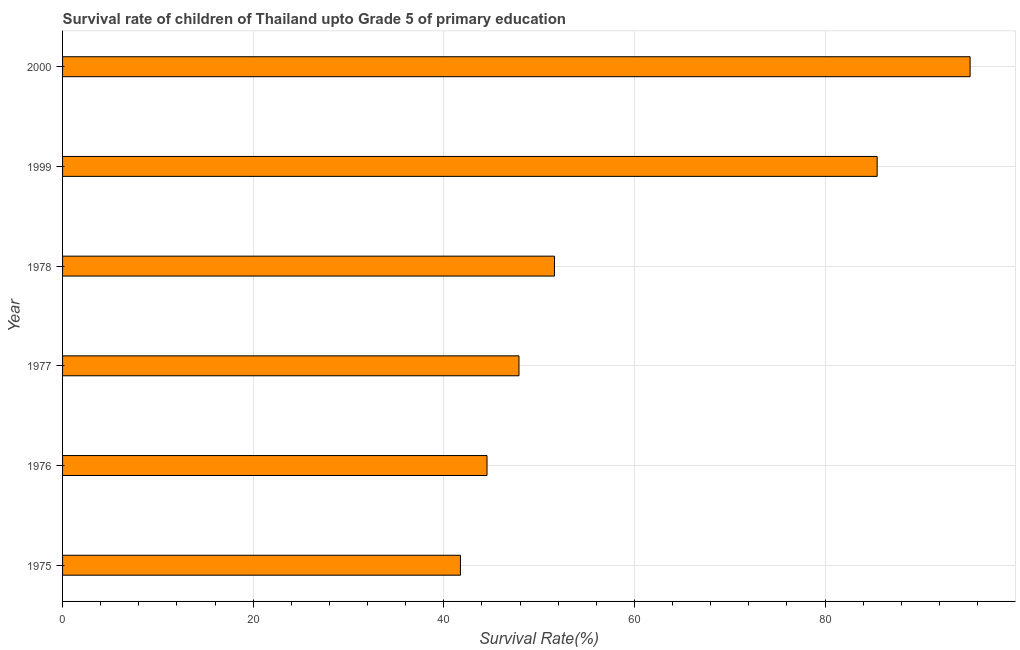Does the graph contain any zero values?
Provide a succinct answer. No. What is the title of the graph?
Your answer should be compact. Survival rate of children of Thailand upto Grade 5 of primary education. What is the label or title of the X-axis?
Keep it short and to the point. Survival Rate(%). What is the survival rate in 2000?
Ensure brevity in your answer.  95.21. Across all years, what is the maximum survival rate?
Provide a short and direct response. 95.21. Across all years, what is the minimum survival rate?
Give a very brief answer. 41.74. In which year was the survival rate minimum?
Provide a short and direct response. 1975. What is the sum of the survival rate?
Provide a succinct answer. 366.43. What is the difference between the survival rate in 1975 and 1978?
Provide a short and direct response. -9.86. What is the average survival rate per year?
Offer a very short reply. 61.07. What is the median survival rate?
Keep it short and to the point. 49.74. In how many years, is the survival rate greater than 76 %?
Make the answer very short. 2. What is the ratio of the survival rate in 1975 to that in 1978?
Offer a very short reply. 0.81. Is the survival rate in 1976 less than that in 1977?
Ensure brevity in your answer.  Yes. What is the difference between the highest and the second highest survival rate?
Make the answer very short. 9.75. What is the difference between the highest and the lowest survival rate?
Ensure brevity in your answer.  53.47. In how many years, is the survival rate greater than the average survival rate taken over all years?
Your response must be concise. 2. How many years are there in the graph?
Provide a short and direct response. 6. What is the Survival Rate(%) in 1975?
Offer a very short reply. 41.74. What is the Survival Rate(%) in 1976?
Provide a short and direct response. 44.53. What is the Survival Rate(%) of 1977?
Ensure brevity in your answer.  47.88. What is the Survival Rate(%) of 1978?
Provide a short and direct response. 51.6. What is the Survival Rate(%) in 1999?
Your answer should be very brief. 85.46. What is the Survival Rate(%) of 2000?
Your answer should be very brief. 95.21. What is the difference between the Survival Rate(%) in 1975 and 1976?
Make the answer very short. -2.79. What is the difference between the Survival Rate(%) in 1975 and 1977?
Keep it short and to the point. -6.14. What is the difference between the Survival Rate(%) in 1975 and 1978?
Your answer should be very brief. -9.86. What is the difference between the Survival Rate(%) in 1975 and 1999?
Provide a short and direct response. -43.72. What is the difference between the Survival Rate(%) in 1975 and 2000?
Make the answer very short. -53.47. What is the difference between the Survival Rate(%) in 1976 and 1977?
Your answer should be very brief. -3.35. What is the difference between the Survival Rate(%) in 1976 and 1978?
Your answer should be very brief. -7.07. What is the difference between the Survival Rate(%) in 1976 and 1999?
Provide a short and direct response. -40.93. What is the difference between the Survival Rate(%) in 1976 and 2000?
Your answer should be very brief. -50.68. What is the difference between the Survival Rate(%) in 1977 and 1978?
Your response must be concise. -3.72. What is the difference between the Survival Rate(%) in 1977 and 1999?
Your response must be concise. -37.58. What is the difference between the Survival Rate(%) in 1977 and 2000?
Your answer should be compact. -47.33. What is the difference between the Survival Rate(%) in 1978 and 1999?
Provide a succinct answer. -33.86. What is the difference between the Survival Rate(%) in 1978 and 2000?
Your response must be concise. -43.61. What is the difference between the Survival Rate(%) in 1999 and 2000?
Your answer should be compact. -9.75. What is the ratio of the Survival Rate(%) in 1975 to that in 1976?
Offer a very short reply. 0.94. What is the ratio of the Survival Rate(%) in 1975 to that in 1977?
Offer a very short reply. 0.87. What is the ratio of the Survival Rate(%) in 1975 to that in 1978?
Make the answer very short. 0.81. What is the ratio of the Survival Rate(%) in 1975 to that in 1999?
Ensure brevity in your answer.  0.49. What is the ratio of the Survival Rate(%) in 1975 to that in 2000?
Offer a terse response. 0.44. What is the ratio of the Survival Rate(%) in 1976 to that in 1978?
Your answer should be very brief. 0.86. What is the ratio of the Survival Rate(%) in 1976 to that in 1999?
Your response must be concise. 0.52. What is the ratio of the Survival Rate(%) in 1976 to that in 2000?
Provide a short and direct response. 0.47. What is the ratio of the Survival Rate(%) in 1977 to that in 1978?
Provide a short and direct response. 0.93. What is the ratio of the Survival Rate(%) in 1977 to that in 1999?
Your answer should be very brief. 0.56. What is the ratio of the Survival Rate(%) in 1977 to that in 2000?
Offer a very short reply. 0.5. What is the ratio of the Survival Rate(%) in 1978 to that in 1999?
Keep it short and to the point. 0.6. What is the ratio of the Survival Rate(%) in 1978 to that in 2000?
Offer a very short reply. 0.54. What is the ratio of the Survival Rate(%) in 1999 to that in 2000?
Your answer should be compact. 0.9. 